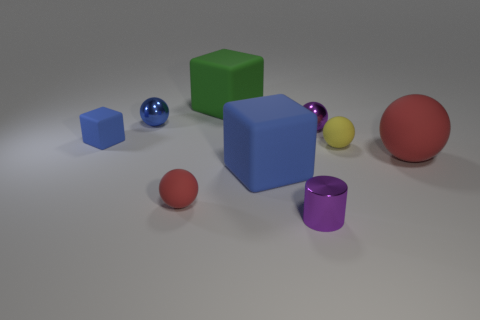The tiny purple object in front of the small purple sphere has what shape?
Your answer should be compact. Cylinder. There is a large block that is the same color as the tiny rubber block; what material is it?
Provide a short and direct response. Rubber. What number of other objects are the same material as the yellow object?
Your answer should be very brief. 5. There is a tiny yellow thing; is it the same shape as the red object that is on the right side of the purple metal cylinder?
Keep it short and to the point. Yes. There is a blue object that is the same material as the small purple cylinder; what shape is it?
Give a very brief answer. Sphere. Is the number of yellow spheres that are to the left of the purple cylinder greater than the number of big red spheres left of the tiny blue rubber object?
Provide a short and direct response. No. What number of objects are either blue spheres or tiny purple balls?
Offer a terse response. 2. What number of other things are there of the same color as the small block?
Your answer should be compact. 2. The red object that is the same size as the cylinder is what shape?
Give a very brief answer. Sphere. There is a metal thing in front of the large rubber sphere; what is its color?
Your answer should be very brief. Purple. 